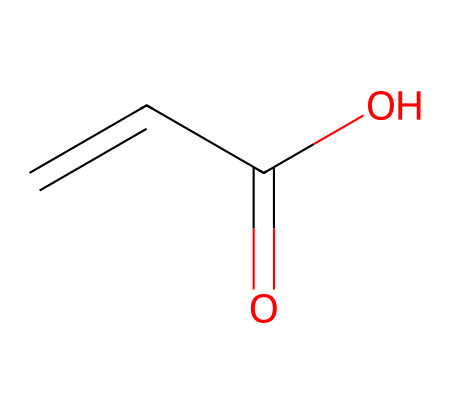What is the name of this chemical? The chemical represented by the SMILES notation C=CC(=O)O is known as acrylic acid. This is determined by recognizing the structural features in the SMILES, specifically the presence of the carboxylic acid functional group (-COOH) and the double bond (C=C) characteristic to acrylics.
Answer: acrylic acid How many carbon atoms are in this chemical? The SMILES notation C=CC(=O)O indicates there are three carbon atoms. This can be deduced by counting the 'C' characters in the SMILES string, where there are three individual 'C' and one connected through double bonds and a functional group.
Answer: three What kind of functional group is present in acrylic acid? The C=CC(=O)O structure contains a carboxylic acid functional group (-COOH). This is evident from the presence of the carbon atom connected to both a hydroxyl group (O) and a carbonyl group (C=O).
Answer: carboxylic acid What is the total number of hydrogen atoms in this chemical? In the structure given by the SMILES notation, there are four hydrogen atoms. This can be calculated by observing the bonding: each carbon is typically tetravalent. The presence of double bonds and functional groups modifies the total hydrogens, ensuring that carbon atoms complete their tetravalence.
Answer: four What type of polymer can be produced from acrylic acid? Acrylic acid can be polymerized to form polyacrylic acid, which is a common polymer used in various applications such as adhesives, superabsorbent materials, and more. This is a standard process in polymer chemistry where the monomer (acrylic acid) links together to create larger chain-like structures.
Answer: polyacrylic acid Which type of bond is present between the first two carbon atoms? The first two carbon atoms are connected by a double bond, indicated by the '=' in the SMILES notation. Recognizing the positioning of the '=' sign leads to the conclusion that it represents a double bond in organic chemistry.
Answer: double bond 